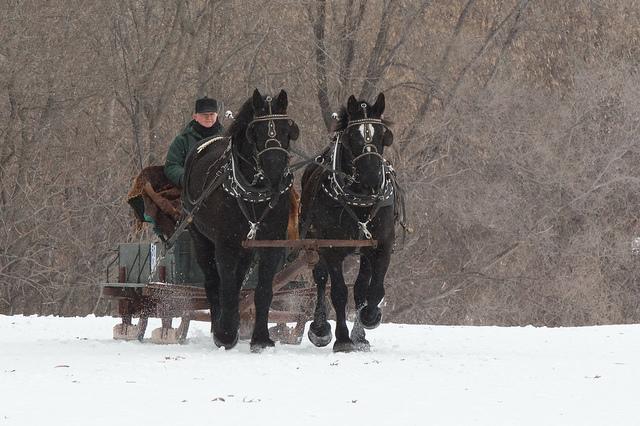How many horses are shown?
Give a very brief answer. 2. How many horses are there?
Give a very brief answer. 2. How many yellow banana do you see in the picture?
Give a very brief answer. 0. 